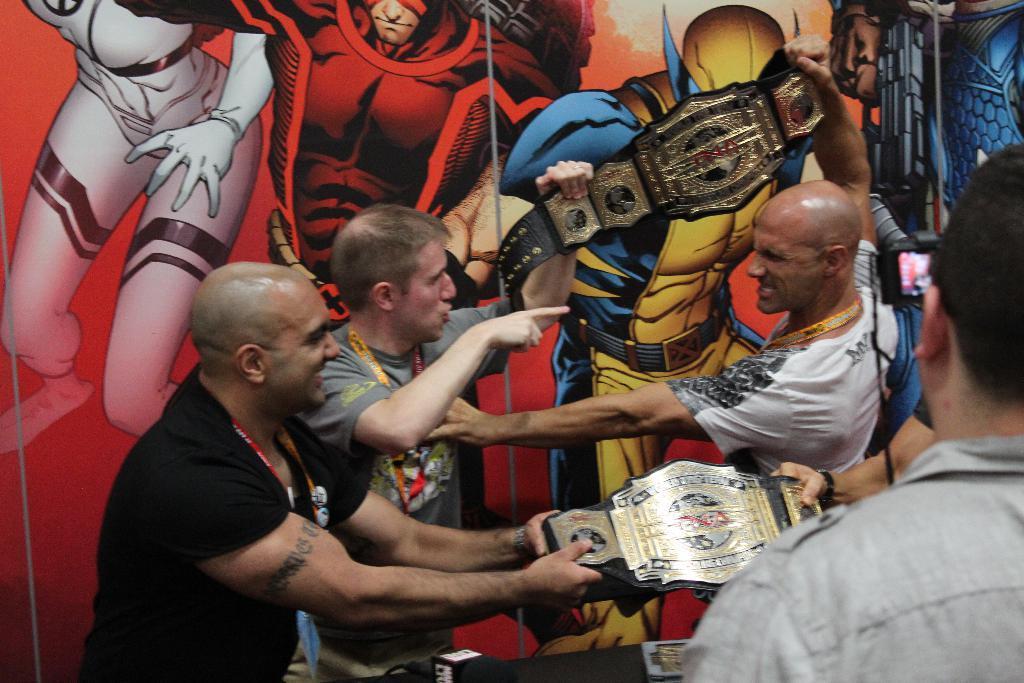Describe this image in one or two sentences. In this image I can see four people with different color dresses. I can see these people are holding the belt and one person is holding the camera. In the background I can see the wall which is in colorful. 